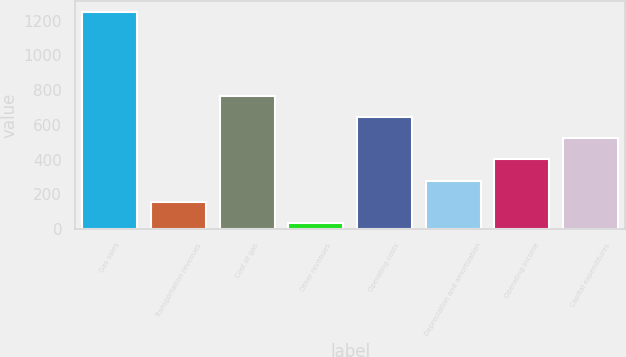Convert chart. <chart><loc_0><loc_0><loc_500><loc_500><bar_chart><fcel>Gas sales<fcel>Transportation revenues<fcel>Cost of gas<fcel>Other revenues<fcel>Operating costs<fcel>Depreciation and amortization<fcel>Operating income<fcel>Capital expenditures<nl><fcel>1252<fcel>157.42<fcel>765.52<fcel>35.8<fcel>643.9<fcel>279.04<fcel>400.66<fcel>522.28<nl></chart> 